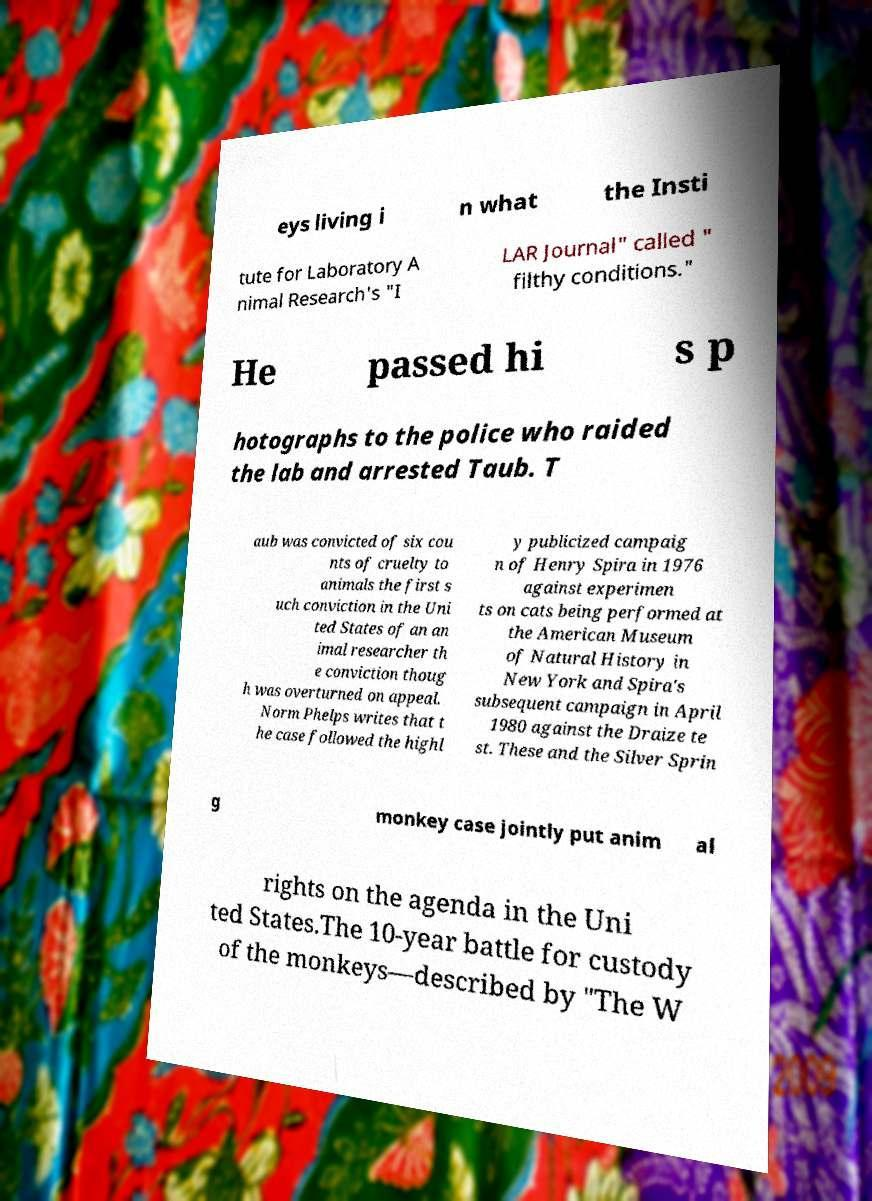Please identify and transcribe the text found in this image. eys living i n what the Insti tute for Laboratory A nimal Research's "I LAR Journal" called " filthy conditions." He passed hi s p hotographs to the police who raided the lab and arrested Taub. T aub was convicted of six cou nts of cruelty to animals the first s uch conviction in the Uni ted States of an an imal researcher th e conviction thoug h was overturned on appeal. Norm Phelps writes that t he case followed the highl y publicized campaig n of Henry Spira in 1976 against experimen ts on cats being performed at the American Museum of Natural History in New York and Spira's subsequent campaign in April 1980 against the Draize te st. These and the Silver Sprin g monkey case jointly put anim al rights on the agenda in the Uni ted States.The 10-year battle for custody of the monkeys—described by "The W 